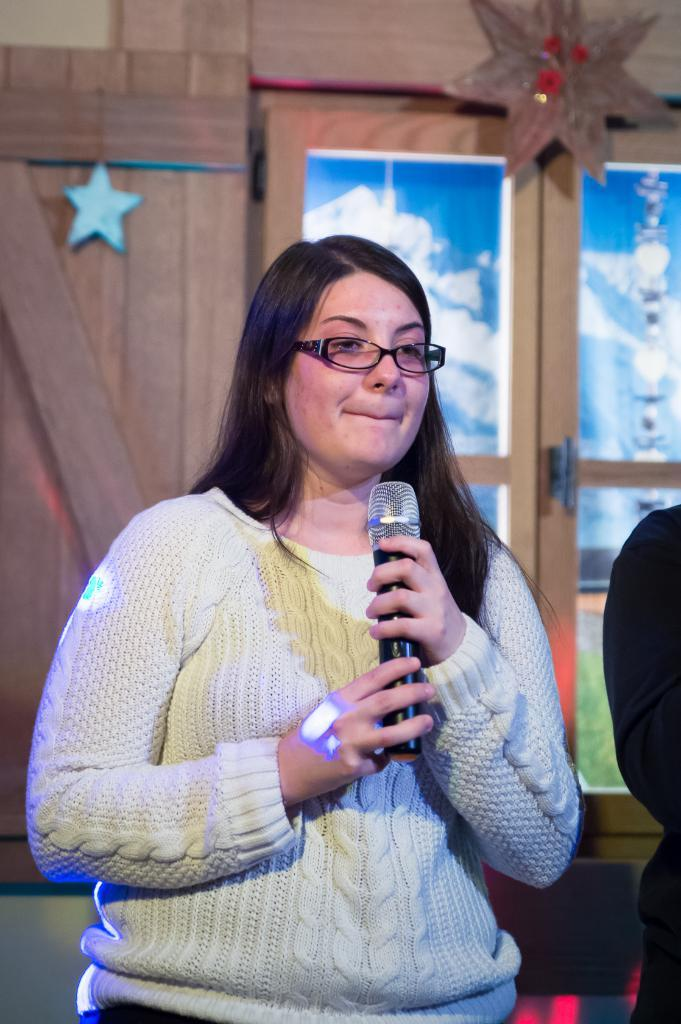What is the woman holding in her hands in the image? The woman is holding a microphone in her hands. What is the woman wearing on her upper body? The woman is wearing a sweater. What accessory is the woman wearing on her face? The woman is wearing spectacles. What expression does the woman have in the image? The woman is smiling. What can be seen in the background of the image? There is a wooden wall in the background. What type of deer can be seen in the image? There are no deer present in the image; it features a woman holding a microphone and a wooden wall in the background. 